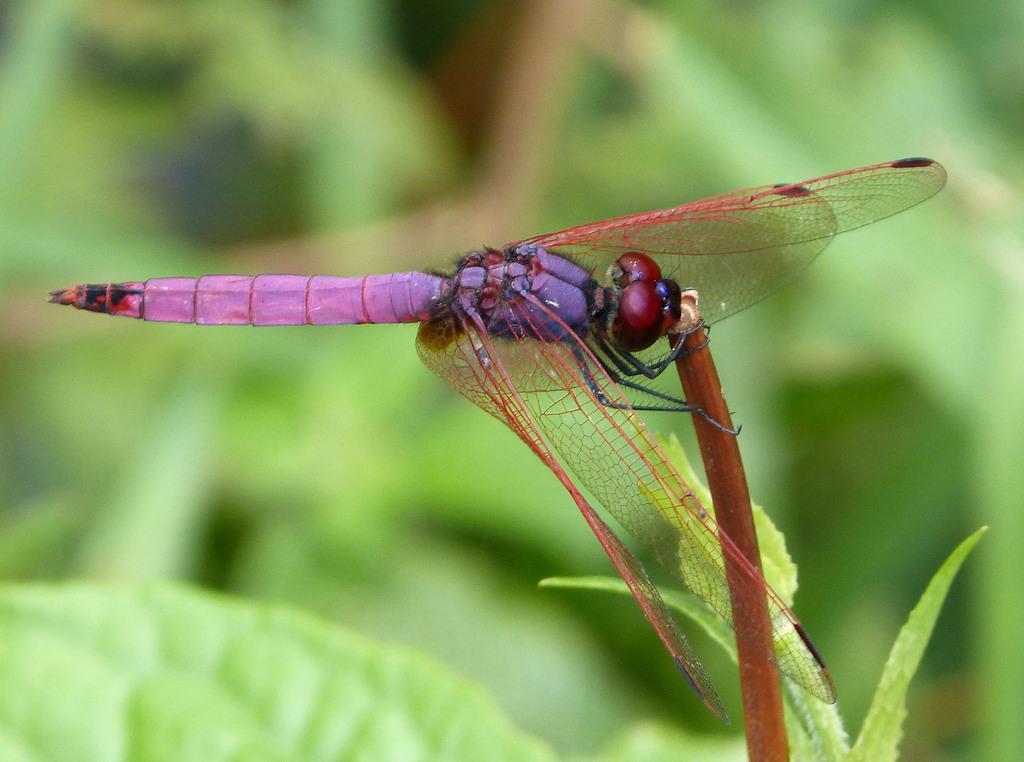How would you summarize this image in a sentence or two? In this image I can see the dragonfly which is in black, brown and purple color. It is on the plant. And there is a blurred background. 